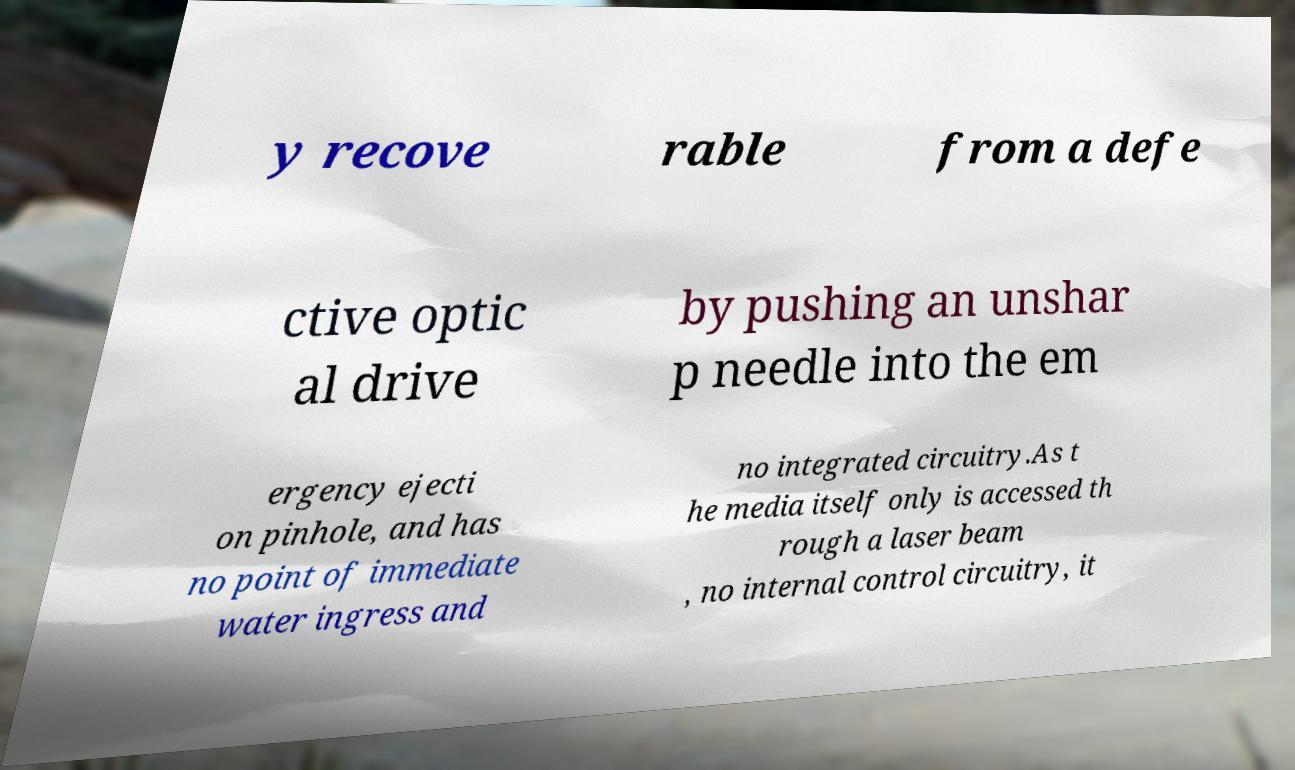I need the written content from this picture converted into text. Can you do that? y recove rable from a defe ctive optic al drive by pushing an unshar p needle into the em ergency ejecti on pinhole, and has no point of immediate water ingress and no integrated circuitry.As t he media itself only is accessed th rough a laser beam , no internal control circuitry, it 